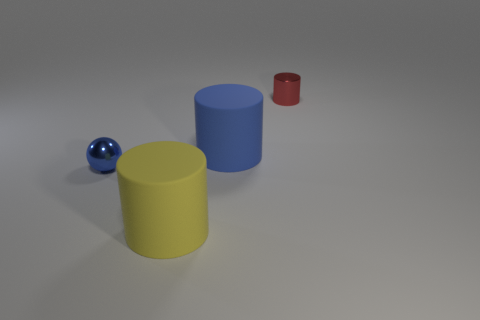Add 1 blue balls. How many objects exist? 5 Subtract all rubber cylinders. How many cylinders are left? 1 Subtract all spheres. How many objects are left? 3 Subtract all cyan cylinders. Subtract all green balls. How many cylinders are left? 3 Subtract all big blue matte cylinders. Subtract all yellow cylinders. How many objects are left? 2 Add 3 red metal things. How many red metal things are left? 4 Add 4 small blue shiny things. How many small blue shiny things exist? 5 Subtract 0 cyan cylinders. How many objects are left? 4 